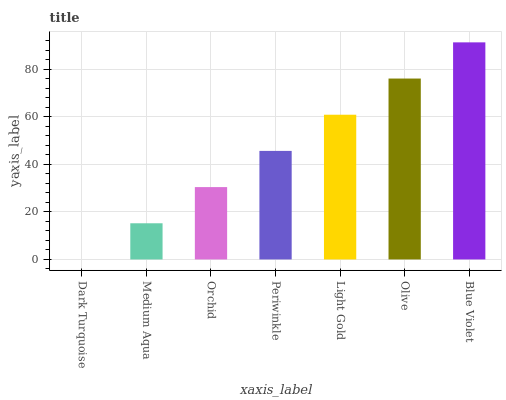Is Dark Turquoise the minimum?
Answer yes or no. Yes. Is Blue Violet the maximum?
Answer yes or no. Yes. Is Medium Aqua the minimum?
Answer yes or no. No. Is Medium Aqua the maximum?
Answer yes or no. No. Is Medium Aqua greater than Dark Turquoise?
Answer yes or no. Yes. Is Dark Turquoise less than Medium Aqua?
Answer yes or no. Yes. Is Dark Turquoise greater than Medium Aqua?
Answer yes or no. No. Is Medium Aqua less than Dark Turquoise?
Answer yes or no. No. Is Periwinkle the high median?
Answer yes or no. Yes. Is Periwinkle the low median?
Answer yes or no. Yes. Is Medium Aqua the high median?
Answer yes or no. No. Is Orchid the low median?
Answer yes or no. No. 